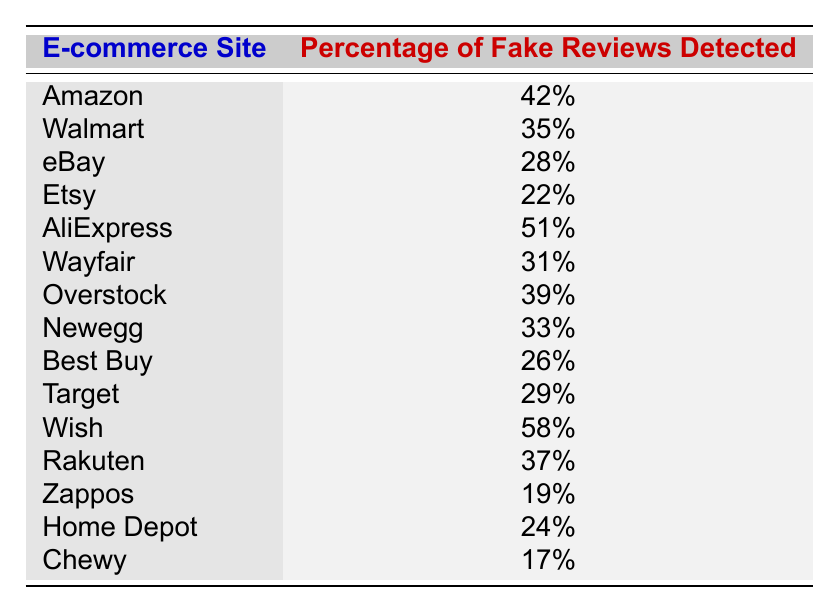What is the highest percentage of fake reviews detected? The table shows all the percentages for each e-commerce site. By reviewing the data, I can see that Wish has the highest percentage at 58%.
Answer: 58% Which e-commerce site has the lowest percentage of fake reviews? A quick glance at the table reveals that Chewy has the lowest percentage of fake reviews detected at 17%.
Answer: 17% What is the percentage of fake reviews on eBay? According to the table, eBay's percentage of fake reviews detected is 28%.
Answer: 28% How many e-commerce sites have more than 40% fake reviews? By scanning the table, there are four sites—Amazon, AliExpress, Overstock, and Wish—that have more than 40% fake reviews (42%, 51%, 39%, and 58% respectively).
Answer: 4 What is the average percentage of fake reviews for the sites listed? To calculate the average, I must first sum the percentages of all the sites and then divide by the number of sites. The total fake reviews percentages are 42 + 35 + 28 + 22 + 51 + 31 + 39 + 33 + 26 + 29 + 58 + 37 + 19 + 24 + 17 =  404, and there are 15 sites. Thus, the average is 404/15 = 26.93%.
Answer: 26.93% Is it true that all sites have more than 20% fake reviews? I can verify the data in the table to answer this. Chewy has 17%, which is below 20%. Therefore, the statement is false.
Answer: No What percentage of fake reviews does Walmart have compared to Target? The table indicates Walmart has 35% and Target has 29%, showing that Walmart has higher fake reviews than Target by a margin of 6%.
Answer: 35% (Walmart), 29% (Target) Which site has a higher percentage: Wayfair or Newegg? The table provides the percentages for both; Wayfair has 31%, and Newegg has 33%. Comparing these, Newegg has a higher percentage of fake reviews by 2%.
Answer: Newegg How does the percentage of fake reviews on AliExpress compare to that on Best Buy? Looking at the table, AliExpress has 51% while Best Buy has 26%, which means AliExpress has a significantly higher percentage (25% more than Best Buy).
Answer: 51% (AliExpress), 26% (Best Buy) What is the difference in percentage of fake reviews between Overstock and Rakuten? From the table, Overstock has 39% and Rakuten has 37%. The difference can be calculated as 39% - 37% = 2%.
Answer: 2% Which two sites combined have the most percentage of fake reviews? By reviewing the table, Wish (58%) and AliExpress (51%) have the highest percentages, so combined, they total 58% + 51% = 109%.
Answer: 109% 